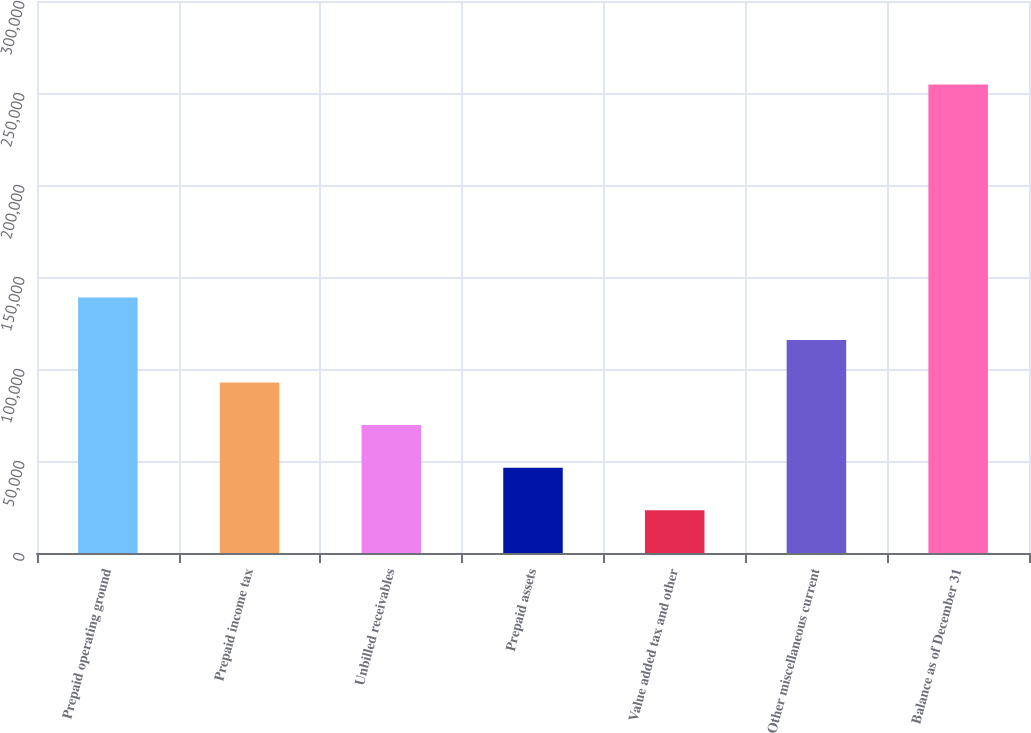Convert chart. <chart><loc_0><loc_0><loc_500><loc_500><bar_chart><fcel>Prepaid operating ground<fcel>Prepaid income tax<fcel>Unbilled receivables<fcel>Prepaid assets<fcel>Value added tax and other<fcel>Other miscellaneous current<fcel>Balance as of December 31<nl><fcel>138925<fcel>92646.2<fcel>69506.8<fcel>46367.4<fcel>23228<fcel>115786<fcel>254622<nl></chart> 